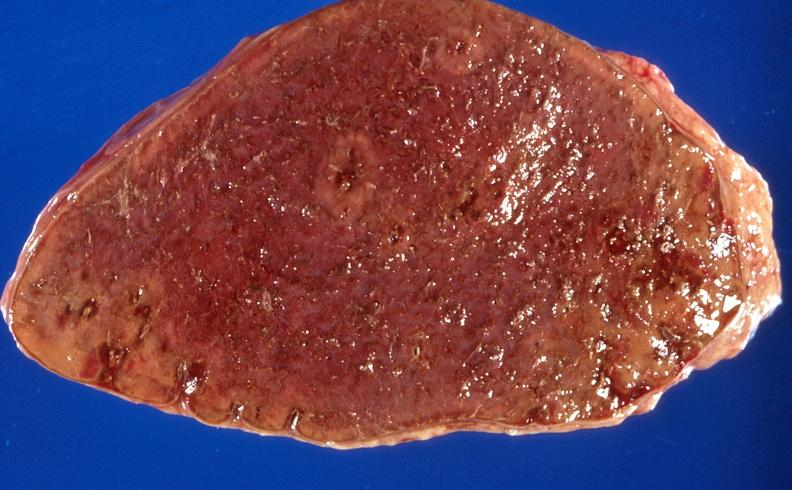s hemorrhage in newborn present?
Answer the question using a single word or phrase. No 